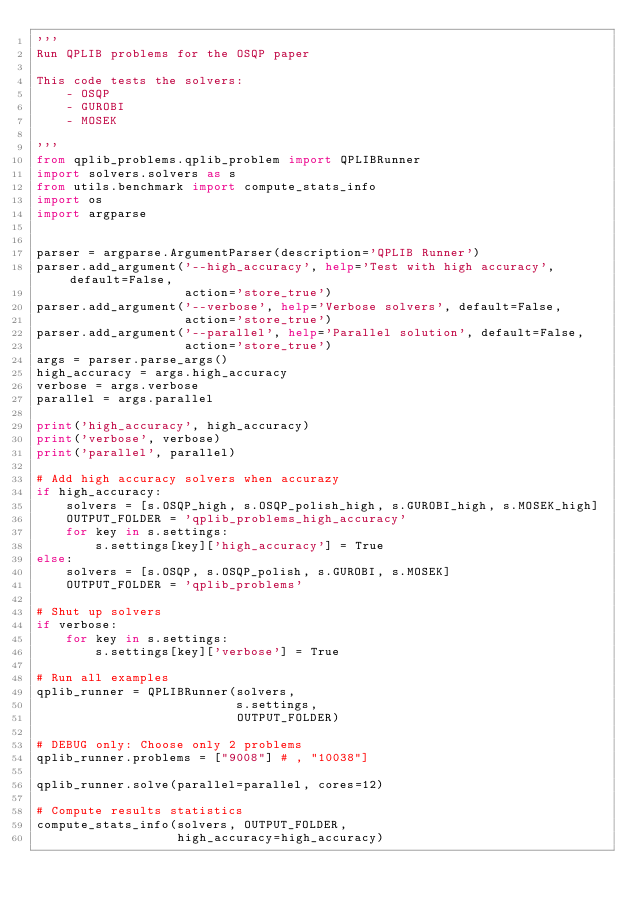<code> <loc_0><loc_0><loc_500><loc_500><_Python_>'''
Run QPLIB problems for the OSQP paper

This code tests the solvers:
    - OSQP
    - GUROBI
    - MOSEK

'''
from qplib_problems.qplib_problem import QPLIBRunner
import solvers.solvers as s
from utils.benchmark import compute_stats_info
import os
import argparse


parser = argparse.ArgumentParser(description='QPLIB Runner')
parser.add_argument('--high_accuracy', help='Test with high accuracy', default=False,
                    action='store_true')
parser.add_argument('--verbose', help='Verbose solvers', default=False,
                    action='store_true')
parser.add_argument('--parallel', help='Parallel solution', default=False,
                    action='store_true')
args = parser.parse_args()
high_accuracy = args.high_accuracy
verbose = args.verbose
parallel = args.parallel

print('high_accuracy', high_accuracy)
print('verbose', verbose)
print('parallel', parallel)

# Add high accuracy solvers when accurazy
if high_accuracy:
    solvers = [s.OSQP_high, s.OSQP_polish_high, s.GUROBI_high, s.MOSEK_high]
    OUTPUT_FOLDER = 'qplib_problems_high_accuracy'
    for key in s.settings:
        s.settings[key]['high_accuracy'] = True
else:
    solvers = [s.OSQP, s.OSQP_polish, s.GUROBI, s.MOSEK]
    OUTPUT_FOLDER = 'qplib_problems'

# Shut up solvers
if verbose:
    for key in s.settings:
        s.settings[key]['verbose'] = True

# Run all examples
qplib_runner = QPLIBRunner(solvers,
                           s.settings,
                           OUTPUT_FOLDER)

# DEBUG only: Choose only 2 problems
qplib_runner.problems = ["9008"] # , "10038"]

qplib_runner.solve(parallel=parallel, cores=12)

# Compute results statistics
compute_stats_info(solvers, OUTPUT_FOLDER,
                   high_accuracy=high_accuracy)
</code> 